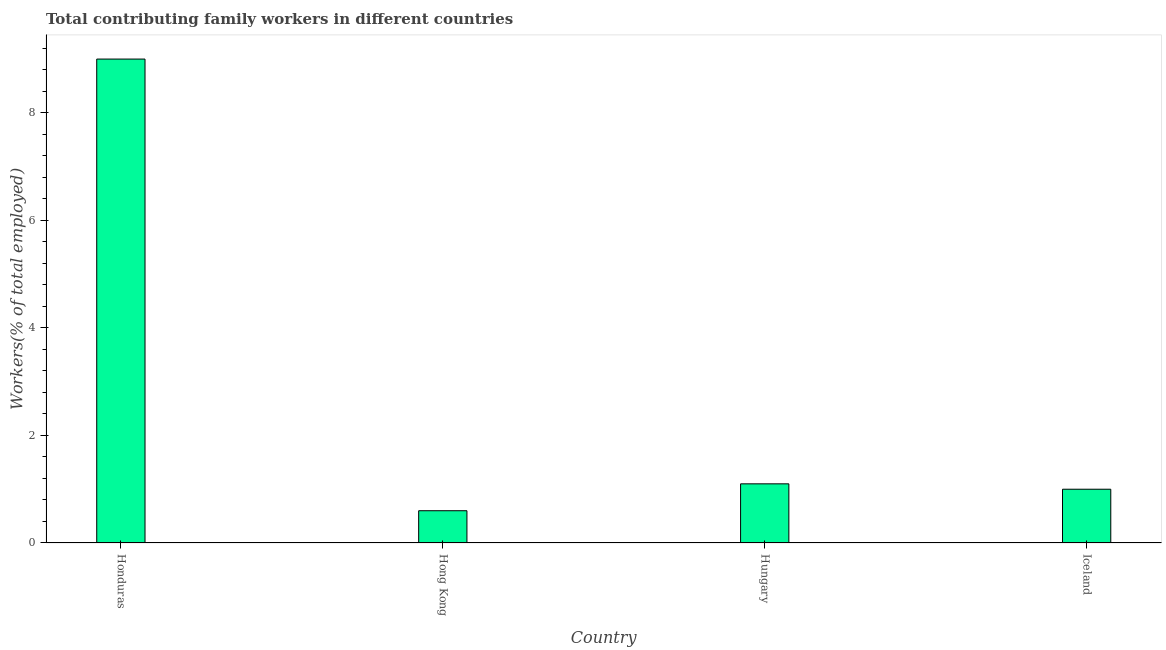Does the graph contain any zero values?
Offer a terse response. No. What is the title of the graph?
Your answer should be compact. Total contributing family workers in different countries. What is the label or title of the Y-axis?
Provide a succinct answer. Workers(% of total employed). What is the contributing family workers in Iceland?
Offer a terse response. 1. Across all countries, what is the minimum contributing family workers?
Make the answer very short. 0.6. In which country was the contributing family workers maximum?
Keep it short and to the point. Honduras. In which country was the contributing family workers minimum?
Make the answer very short. Hong Kong. What is the sum of the contributing family workers?
Offer a terse response. 11.7. What is the average contributing family workers per country?
Your answer should be compact. 2.92. What is the median contributing family workers?
Make the answer very short. 1.05. Is the difference between the contributing family workers in Hong Kong and Hungary greater than the difference between any two countries?
Keep it short and to the point. No. What is the difference between the highest and the lowest contributing family workers?
Your response must be concise. 8.4. How many bars are there?
Keep it short and to the point. 4. How many countries are there in the graph?
Give a very brief answer. 4. What is the Workers(% of total employed) in Honduras?
Offer a terse response. 9. What is the Workers(% of total employed) in Hong Kong?
Ensure brevity in your answer.  0.6. What is the Workers(% of total employed) in Hungary?
Make the answer very short. 1.1. What is the difference between the Workers(% of total employed) in Honduras and Hong Kong?
Offer a very short reply. 8.4. What is the difference between the Workers(% of total employed) in Hong Kong and Iceland?
Give a very brief answer. -0.4. What is the difference between the Workers(% of total employed) in Hungary and Iceland?
Ensure brevity in your answer.  0.1. What is the ratio of the Workers(% of total employed) in Honduras to that in Hungary?
Your answer should be compact. 8.18. What is the ratio of the Workers(% of total employed) in Honduras to that in Iceland?
Offer a terse response. 9. What is the ratio of the Workers(% of total employed) in Hong Kong to that in Hungary?
Offer a very short reply. 0.55. 